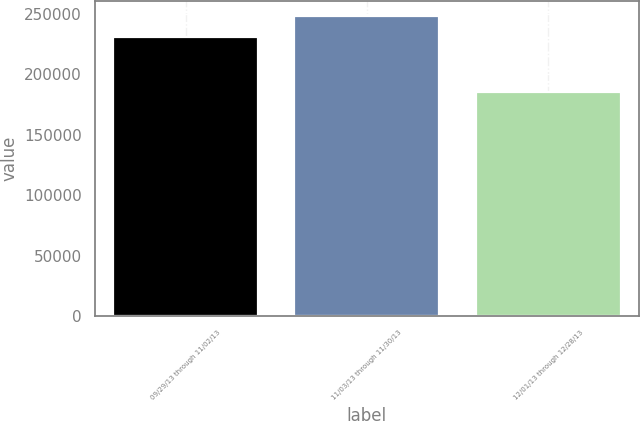Convert chart to OTSL. <chart><loc_0><loc_0><loc_500><loc_500><bar_chart><fcel>09/29/13 through 11/02/13<fcel>11/03/13 through 11/30/13<fcel>12/01/13 through 12/28/13<nl><fcel>231000<fcel>248057<fcel>185300<nl></chart> 